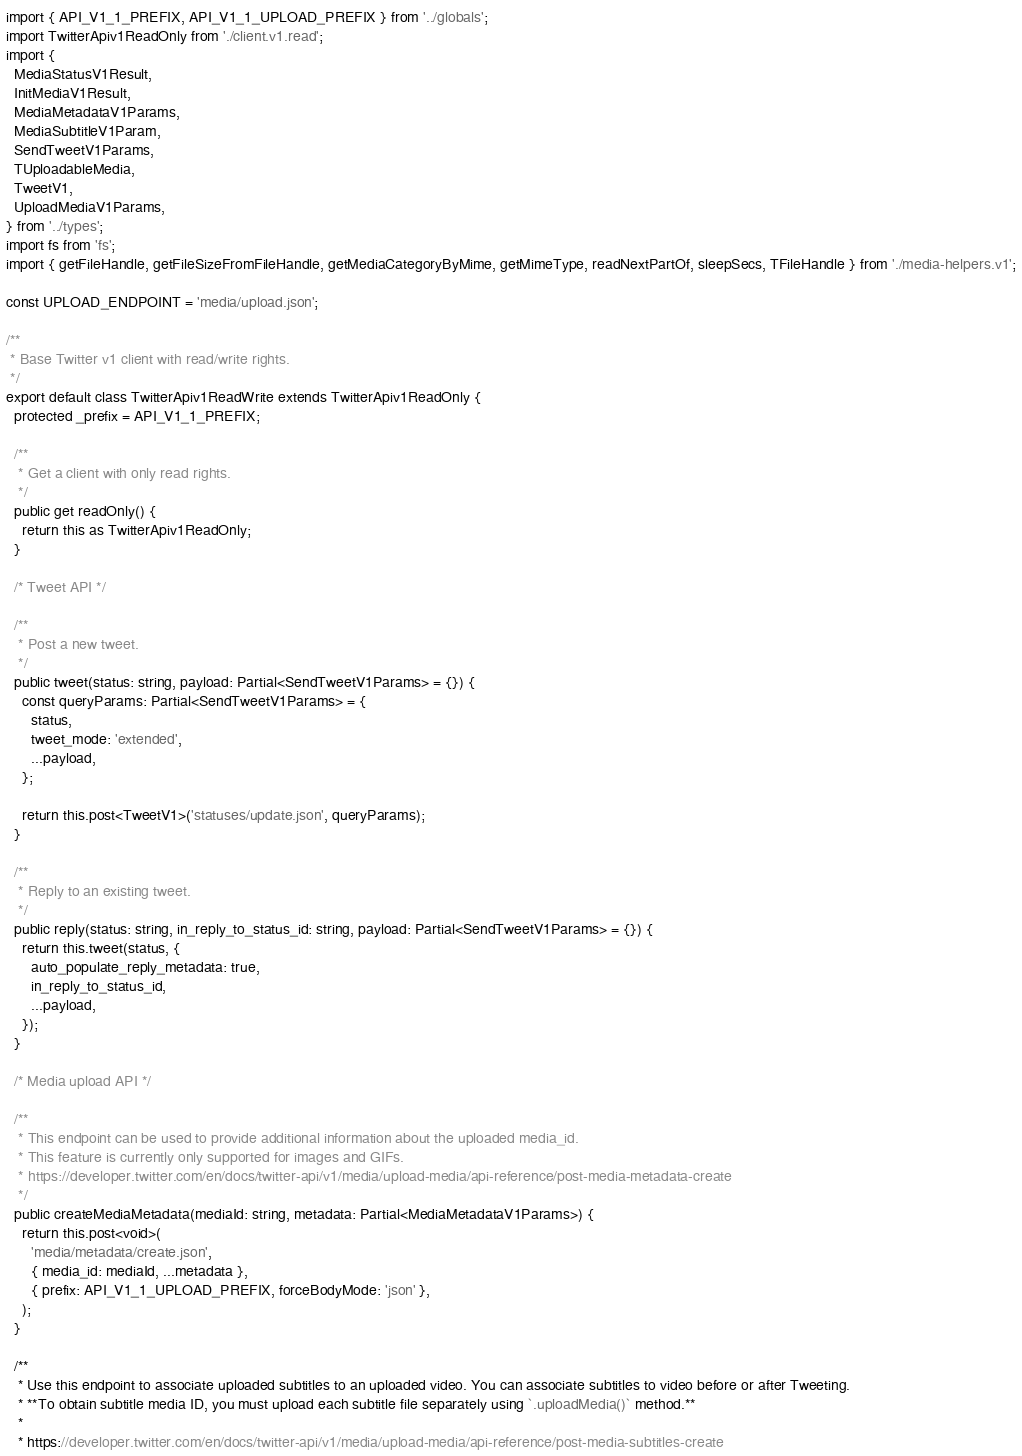<code> <loc_0><loc_0><loc_500><loc_500><_TypeScript_>import { API_V1_1_PREFIX, API_V1_1_UPLOAD_PREFIX } from '../globals';
import TwitterApiv1ReadOnly from './client.v1.read';
import {
  MediaStatusV1Result,
  InitMediaV1Result,
  MediaMetadataV1Params,
  MediaSubtitleV1Param,
  SendTweetV1Params,
  TUploadableMedia,
  TweetV1,
  UploadMediaV1Params,
} from '../types';
import fs from 'fs';
import { getFileHandle, getFileSizeFromFileHandle, getMediaCategoryByMime, getMimeType, readNextPartOf, sleepSecs, TFileHandle } from './media-helpers.v1';

const UPLOAD_ENDPOINT = 'media/upload.json';

/**
 * Base Twitter v1 client with read/write rights.
 */
export default class TwitterApiv1ReadWrite extends TwitterApiv1ReadOnly {
  protected _prefix = API_V1_1_PREFIX;

  /**
   * Get a client with only read rights.
   */
  public get readOnly() {
    return this as TwitterApiv1ReadOnly;
  }

  /* Tweet API */

  /**
   * Post a new tweet.
   */
  public tweet(status: string, payload: Partial<SendTweetV1Params> = {}) {
    const queryParams: Partial<SendTweetV1Params> = {
      status,
      tweet_mode: 'extended',
      ...payload,
    };

    return this.post<TweetV1>('statuses/update.json', queryParams);
  }

  /**
   * Reply to an existing tweet.
   */
  public reply(status: string, in_reply_to_status_id: string, payload: Partial<SendTweetV1Params> = {}) {
    return this.tweet(status, {
      auto_populate_reply_metadata: true,
      in_reply_to_status_id,
      ...payload,
    });
  }

  /* Media upload API */

  /**
   * This endpoint can be used to provide additional information about the uploaded media_id.
   * This feature is currently only supported for images and GIFs.
   * https://developer.twitter.com/en/docs/twitter-api/v1/media/upload-media/api-reference/post-media-metadata-create
   */
  public createMediaMetadata(mediaId: string, metadata: Partial<MediaMetadataV1Params>) {
    return this.post<void>(
      'media/metadata/create.json',
      { media_id: mediaId, ...metadata },
      { prefix: API_V1_1_UPLOAD_PREFIX, forceBodyMode: 'json' },
    );
  }

  /**
   * Use this endpoint to associate uploaded subtitles to an uploaded video. You can associate subtitles to video before or after Tweeting.
   * **To obtain subtitle media ID, you must upload each subtitle file separately using `.uploadMedia()` method.**
   *
   * https://developer.twitter.com/en/docs/twitter-api/v1/media/upload-media/api-reference/post-media-subtitles-create</code> 